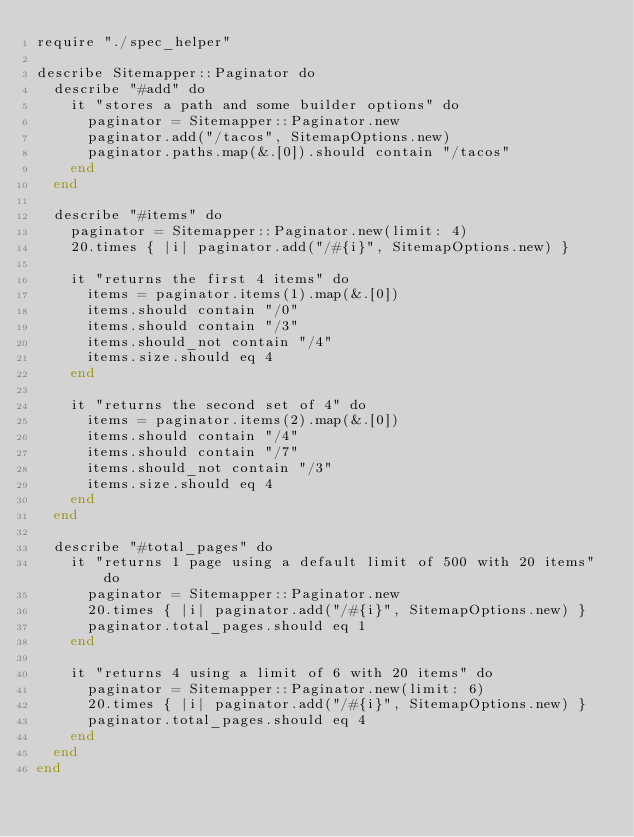<code> <loc_0><loc_0><loc_500><loc_500><_Crystal_>require "./spec_helper"

describe Sitemapper::Paginator do
  describe "#add" do
    it "stores a path and some builder options" do
      paginator = Sitemapper::Paginator.new
      paginator.add("/tacos", SitemapOptions.new)
      paginator.paths.map(&.[0]).should contain "/tacos"
    end
  end

  describe "#items" do
    paginator = Sitemapper::Paginator.new(limit: 4)
    20.times { |i| paginator.add("/#{i}", SitemapOptions.new) }

    it "returns the first 4 items" do
      items = paginator.items(1).map(&.[0])
      items.should contain "/0"
      items.should contain "/3"
      items.should_not contain "/4"
      items.size.should eq 4
    end

    it "returns the second set of 4" do
      items = paginator.items(2).map(&.[0])
      items.should contain "/4"
      items.should contain "/7"
      items.should_not contain "/3"
      items.size.should eq 4
    end
  end

  describe "#total_pages" do
    it "returns 1 page using a default limit of 500 with 20 items" do
      paginator = Sitemapper::Paginator.new
      20.times { |i| paginator.add("/#{i}", SitemapOptions.new) }
      paginator.total_pages.should eq 1
    end

    it "returns 4 using a limit of 6 with 20 items" do
      paginator = Sitemapper::Paginator.new(limit: 6)
      20.times { |i| paginator.add("/#{i}", SitemapOptions.new) }
      paginator.total_pages.should eq 4
    end
  end
end
</code> 